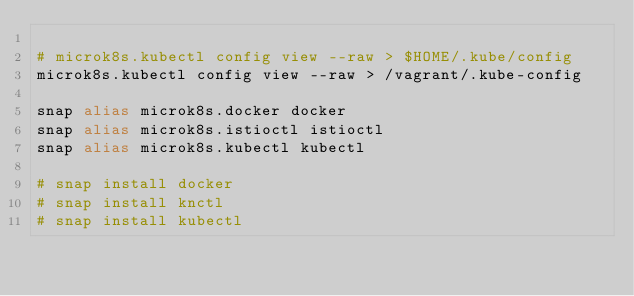Convert code to text. <code><loc_0><loc_0><loc_500><loc_500><_Bash_>
# microk8s.kubectl config view --raw > $HOME/.kube/config
microk8s.kubectl config view --raw > /vagrant/.kube-config

snap alias microk8s.docker docker
snap alias microk8s.istioctl istioctl
snap alias microk8s.kubectl kubectl

# snap install docker
# snap install knctl
# snap install kubectl</code> 